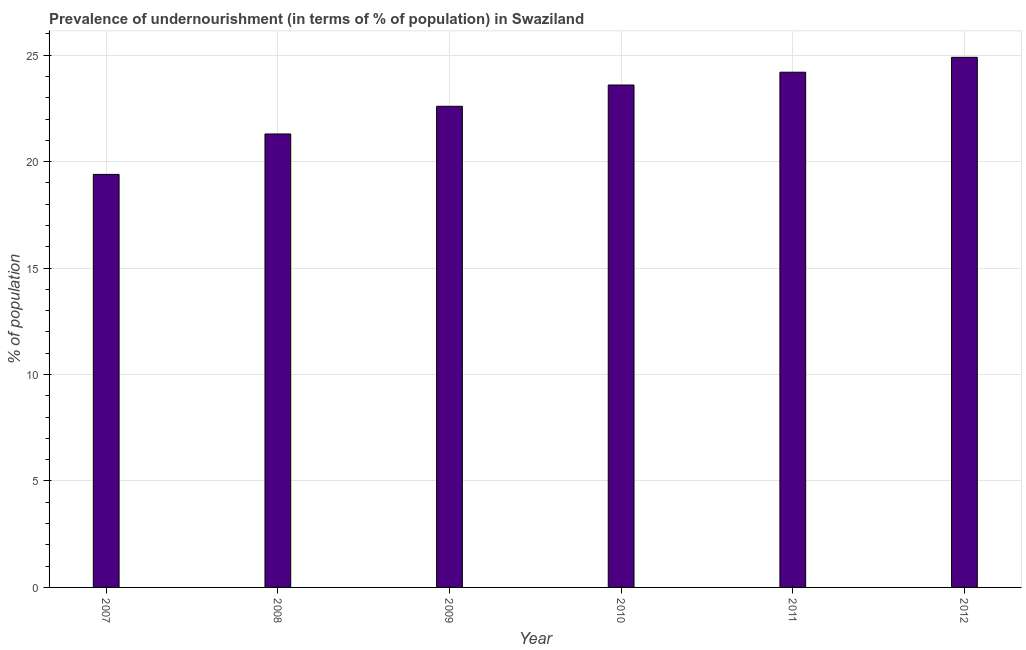Does the graph contain any zero values?
Keep it short and to the point. No. What is the title of the graph?
Make the answer very short. Prevalence of undernourishment (in terms of % of population) in Swaziland. What is the label or title of the Y-axis?
Your answer should be very brief. % of population. What is the percentage of undernourished population in 2009?
Your answer should be compact. 22.6. Across all years, what is the maximum percentage of undernourished population?
Ensure brevity in your answer.  24.9. What is the sum of the percentage of undernourished population?
Your answer should be compact. 136. What is the difference between the percentage of undernourished population in 2010 and 2012?
Your response must be concise. -1.3. What is the average percentage of undernourished population per year?
Keep it short and to the point. 22.67. What is the median percentage of undernourished population?
Provide a short and direct response. 23.1. In how many years, is the percentage of undernourished population greater than 23 %?
Offer a terse response. 3. What is the ratio of the percentage of undernourished population in 2007 to that in 2010?
Ensure brevity in your answer.  0.82. Is the percentage of undernourished population in 2007 less than that in 2010?
Your answer should be very brief. Yes. Is the difference between the percentage of undernourished population in 2008 and 2010 greater than the difference between any two years?
Keep it short and to the point. No. What is the difference between the highest and the second highest percentage of undernourished population?
Offer a very short reply. 0.7. How many bars are there?
Your answer should be very brief. 6. How many years are there in the graph?
Provide a succinct answer. 6. What is the % of population of 2008?
Offer a very short reply. 21.3. What is the % of population in 2009?
Ensure brevity in your answer.  22.6. What is the % of population of 2010?
Provide a short and direct response. 23.6. What is the % of population in 2011?
Your answer should be compact. 24.2. What is the % of population in 2012?
Offer a very short reply. 24.9. What is the difference between the % of population in 2007 and 2008?
Offer a very short reply. -1.9. What is the difference between the % of population in 2008 and 2009?
Your answer should be very brief. -1.3. What is the difference between the % of population in 2008 and 2010?
Your answer should be compact. -2.3. What is the difference between the % of population in 2009 and 2010?
Provide a succinct answer. -1. What is the difference between the % of population in 2010 and 2011?
Offer a very short reply. -0.6. What is the ratio of the % of population in 2007 to that in 2008?
Offer a terse response. 0.91. What is the ratio of the % of population in 2007 to that in 2009?
Provide a succinct answer. 0.86. What is the ratio of the % of population in 2007 to that in 2010?
Make the answer very short. 0.82. What is the ratio of the % of population in 2007 to that in 2011?
Offer a very short reply. 0.8. What is the ratio of the % of population in 2007 to that in 2012?
Provide a succinct answer. 0.78. What is the ratio of the % of population in 2008 to that in 2009?
Your response must be concise. 0.94. What is the ratio of the % of population in 2008 to that in 2010?
Your answer should be compact. 0.9. What is the ratio of the % of population in 2008 to that in 2012?
Your answer should be compact. 0.85. What is the ratio of the % of population in 2009 to that in 2010?
Your answer should be very brief. 0.96. What is the ratio of the % of population in 2009 to that in 2011?
Give a very brief answer. 0.93. What is the ratio of the % of population in 2009 to that in 2012?
Make the answer very short. 0.91. What is the ratio of the % of population in 2010 to that in 2011?
Ensure brevity in your answer.  0.97. What is the ratio of the % of population in 2010 to that in 2012?
Provide a succinct answer. 0.95. What is the ratio of the % of population in 2011 to that in 2012?
Provide a short and direct response. 0.97. 